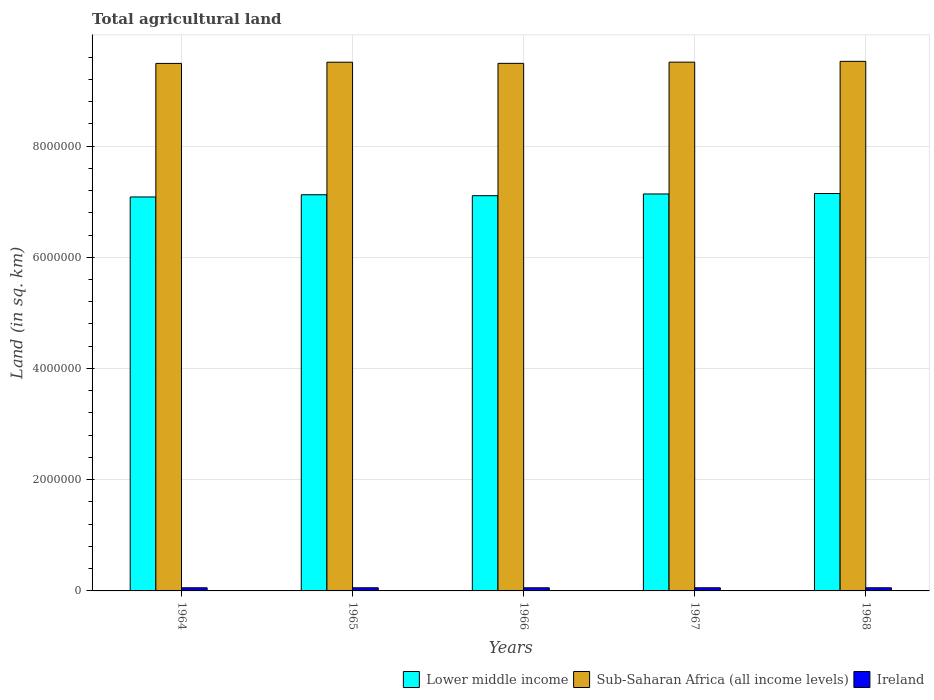What is the label of the 3rd group of bars from the left?
Offer a terse response. 1966. What is the total agricultural land in Lower middle income in 1967?
Ensure brevity in your answer.  7.14e+06. Across all years, what is the maximum total agricultural land in Ireland?
Keep it short and to the point. 5.67e+04. Across all years, what is the minimum total agricultural land in Ireland?
Make the answer very short. 5.64e+04. In which year was the total agricultural land in Lower middle income maximum?
Give a very brief answer. 1968. In which year was the total agricultural land in Sub-Saharan Africa (all income levels) minimum?
Make the answer very short. 1964. What is the total total agricultural land in Sub-Saharan Africa (all income levels) in the graph?
Your answer should be very brief. 4.75e+07. What is the difference between the total agricultural land in Lower middle income in 1965 and that in 1966?
Make the answer very short. 1.69e+04. What is the difference between the total agricultural land in Sub-Saharan Africa (all income levels) in 1968 and the total agricultural land in Ireland in 1964?
Provide a short and direct response. 9.47e+06. What is the average total agricultural land in Sub-Saharan Africa (all income levels) per year?
Provide a succinct answer. 9.50e+06. In the year 1964, what is the difference between the total agricultural land in Lower middle income and total agricultural land in Ireland?
Offer a very short reply. 7.03e+06. In how many years, is the total agricultural land in Lower middle income greater than 3200000 sq.km?
Make the answer very short. 5. What is the ratio of the total agricultural land in Sub-Saharan Africa (all income levels) in 1964 to that in 1968?
Keep it short and to the point. 1. Is the total agricultural land in Ireland in 1966 less than that in 1968?
Give a very brief answer. Yes. Is the difference between the total agricultural land in Lower middle income in 1967 and 1968 greater than the difference between the total agricultural land in Ireland in 1967 and 1968?
Provide a succinct answer. No. What is the difference between the highest and the second highest total agricultural land in Sub-Saharan Africa (all income levels)?
Your response must be concise. 1.42e+04. What is the difference between the highest and the lowest total agricultural land in Sub-Saharan Africa (all income levels)?
Ensure brevity in your answer.  3.70e+04. What does the 2nd bar from the left in 1966 represents?
Offer a terse response. Sub-Saharan Africa (all income levels). What does the 2nd bar from the right in 1967 represents?
Your response must be concise. Sub-Saharan Africa (all income levels). Is it the case that in every year, the sum of the total agricultural land in Lower middle income and total agricultural land in Sub-Saharan Africa (all income levels) is greater than the total agricultural land in Ireland?
Make the answer very short. Yes. Are all the bars in the graph horizontal?
Offer a very short reply. No. How many years are there in the graph?
Your answer should be compact. 5. What is the difference between two consecutive major ticks on the Y-axis?
Offer a terse response. 2.00e+06. Where does the legend appear in the graph?
Keep it short and to the point. Bottom right. How many legend labels are there?
Offer a terse response. 3. How are the legend labels stacked?
Your response must be concise. Horizontal. What is the title of the graph?
Your answer should be very brief. Total agricultural land. Does "Tunisia" appear as one of the legend labels in the graph?
Your answer should be compact. No. What is the label or title of the Y-axis?
Keep it short and to the point. Land (in sq. km). What is the Land (in sq. km) of Lower middle income in 1964?
Ensure brevity in your answer.  7.08e+06. What is the Land (in sq. km) in Sub-Saharan Africa (all income levels) in 1964?
Keep it short and to the point. 9.49e+06. What is the Land (in sq. km) in Ireland in 1964?
Your answer should be compact. 5.67e+04. What is the Land (in sq. km) of Lower middle income in 1965?
Make the answer very short. 7.12e+06. What is the Land (in sq. km) in Sub-Saharan Africa (all income levels) in 1965?
Your answer should be very brief. 9.51e+06. What is the Land (in sq. km) in Ireland in 1965?
Make the answer very short. 5.66e+04. What is the Land (in sq. km) in Lower middle income in 1966?
Offer a very short reply. 7.11e+06. What is the Land (in sq. km) in Sub-Saharan Africa (all income levels) in 1966?
Give a very brief answer. 9.49e+06. What is the Land (in sq. km) in Ireland in 1966?
Give a very brief answer. 5.64e+04. What is the Land (in sq. km) of Lower middle income in 1967?
Ensure brevity in your answer.  7.14e+06. What is the Land (in sq. km) of Sub-Saharan Africa (all income levels) in 1967?
Your response must be concise. 9.51e+06. What is the Land (in sq. km) in Ireland in 1967?
Ensure brevity in your answer.  5.65e+04. What is the Land (in sq. km) of Lower middle income in 1968?
Provide a short and direct response. 7.15e+06. What is the Land (in sq. km) of Sub-Saharan Africa (all income levels) in 1968?
Your answer should be compact. 9.52e+06. What is the Land (in sq. km) in Ireland in 1968?
Your answer should be very brief. 5.67e+04. Across all years, what is the maximum Land (in sq. km) of Lower middle income?
Ensure brevity in your answer.  7.15e+06. Across all years, what is the maximum Land (in sq. km) in Sub-Saharan Africa (all income levels)?
Provide a short and direct response. 9.52e+06. Across all years, what is the maximum Land (in sq. km) of Ireland?
Your response must be concise. 5.67e+04. Across all years, what is the minimum Land (in sq. km) of Lower middle income?
Make the answer very short. 7.08e+06. Across all years, what is the minimum Land (in sq. km) of Sub-Saharan Africa (all income levels)?
Ensure brevity in your answer.  9.49e+06. Across all years, what is the minimum Land (in sq. km) in Ireland?
Ensure brevity in your answer.  5.64e+04. What is the total Land (in sq. km) of Lower middle income in the graph?
Your answer should be compact. 3.56e+07. What is the total Land (in sq. km) of Sub-Saharan Africa (all income levels) in the graph?
Provide a succinct answer. 4.75e+07. What is the total Land (in sq. km) in Ireland in the graph?
Ensure brevity in your answer.  2.83e+05. What is the difference between the Land (in sq. km) of Lower middle income in 1964 and that in 1965?
Keep it short and to the point. -3.97e+04. What is the difference between the Land (in sq. km) of Sub-Saharan Africa (all income levels) in 1964 and that in 1965?
Keep it short and to the point. -2.16e+04. What is the difference between the Land (in sq. km) of Lower middle income in 1964 and that in 1966?
Your answer should be compact. -2.28e+04. What is the difference between the Land (in sq. km) in Sub-Saharan Africa (all income levels) in 1964 and that in 1966?
Make the answer very short. -1059.2. What is the difference between the Land (in sq. km) of Ireland in 1964 and that in 1966?
Ensure brevity in your answer.  310. What is the difference between the Land (in sq. km) in Lower middle income in 1964 and that in 1967?
Your answer should be very brief. -5.39e+04. What is the difference between the Land (in sq. km) of Sub-Saharan Africa (all income levels) in 1964 and that in 1967?
Keep it short and to the point. -2.28e+04. What is the difference between the Land (in sq. km) in Ireland in 1964 and that in 1967?
Provide a succinct answer. 120. What is the difference between the Land (in sq. km) of Lower middle income in 1964 and that in 1968?
Your response must be concise. -6.18e+04. What is the difference between the Land (in sq. km) of Sub-Saharan Africa (all income levels) in 1964 and that in 1968?
Your response must be concise. -3.70e+04. What is the difference between the Land (in sq. km) in Ireland in 1964 and that in 1968?
Offer a very short reply. -80. What is the difference between the Land (in sq. km) of Lower middle income in 1965 and that in 1966?
Make the answer very short. 1.69e+04. What is the difference between the Land (in sq. km) of Sub-Saharan Africa (all income levels) in 1965 and that in 1966?
Make the answer very short. 2.05e+04. What is the difference between the Land (in sq. km) of Ireland in 1965 and that in 1966?
Give a very brief answer. 270. What is the difference between the Land (in sq. km) of Lower middle income in 1965 and that in 1967?
Your answer should be compact. -1.42e+04. What is the difference between the Land (in sq. km) of Sub-Saharan Africa (all income levels) in 1965 and that in 1967?
Provide a succinct answer. -1287.4. What is the difference between the Land (in sq. km) of Ireland in 1965 and that in 1967?
Give a very brief answer. 80. What is the difference between the Land (in sq. km) in Lower middle income in 1965 and that in 1968?
Provide a succinct answer. -2.21e+04. What is the difference between the Land (in sq. km) of Sub-Saharan Africa (all income levels) in 1965 and that in 1968?
Provide a succinct answer. -1.55e+04. What is the difference between the Land (in sq. km) of Ireland in 1965 and that in 1968?
Offer a very short reply. -120. What is the difference between the Land (in sq. km) in Lower middle income in 1966 and that in 1967?
Your response must be concise. -3.10e+04. What is the difference between the Land (in sq. km) of Sub-Saharan Africa (all income levels) in 1966 and that in 1967?
Keep it short and to the point. -2.18e+04. What is the difference between the Land (in sq. km) in Ireland in 1966 and that in 1967?
Your response must be concise. -190. What is the difference between the Land (in sq. km) of Lower middle income in 1966 and that in 1968?
Provide a succinct answer. -3.90e+04. What is the difference between the Land (in sq. km) of Sub-Saharan Africa (all income levels) in 1966 and that in 1968?
Your answer should be compact. -3.60e+04. What is the difference between the Land (in sq. km) in Ireland in 1966 and that in 1968?
Ensure brevity in your answer.  -390. What is the difference between the Land (in sq. km) in Lower middle income in 1967 and that in 1968?
Provide a succinct answer. -7960.8. What is the difference between the Land (in sq. km) in Sub-Saharan Africa (all income levels) in 1967 and that in 1968?
Your answer should be very brief. -1.42e+04. What is the difference between the Land (in sq. km) in Ireland in 1967 and that in 1968?
Give a very brief answer. -200. What is the difference between the Land (in sq. km) of Lower middle income in 1964 and the Land (in sq. km) of Sub-Saharan Africa (all income levels) in 1965?
Give a very brief answer. -2.42e+06. What is the difference between the Land (in sq. km) in Lower middle income in 1964 and the Land (in sq. km) in Ireland in 1965?
Give a very brief answer. 7.03e+06. What is the difference between the Land (in sq. km) of Sub-Saharan Africa (all income levels) in 1964 and the Land (in sq. km) of Ireland in 1965?
Keep it short and to the point. 9.43e+06. What is the difference between the Land (in sq. km) in Lower middle income in 1964 and the Land (in sq. km) in Sub-Saharan Africa (all income levels) in 1966?
Offer a terse response. -2.40e+06. What is the difference between the Land (in sq. km) in Lower middle income in 1964 and the Land (in sq. km) in Ireland in 1966?
Your answer should be very brief. 7.03e+06. What is the difference between the Land (in sq. km) of Sub-Saharan Africa (all income levels) in 1964 and the Land (in sq. km) of Ireland in 1966?
Offer a very short reply. 9.43e+06. What is the difference between the Land (in sq. km) of Lower middle income in 1964 and the Land (in sq. km) of Sub-Saharan Africa (all income levels) in 1967?
Give a very brief answer. -2.42e+06. What is the difference between the Land (in sq. km) in Lower middle income in 1964 and the Land (in sq. km) in Ireland in 1967?
Your response must be concise. 7.03e+06. What is the difference between the Land (in sq. km) of Sub-Saharan Africa (all income levels) in 1964 and the Land (in sq. km) of Ireland in 1967?
Your answer should be compact. 9.43e+06. What is the difference between the Land (in sq. km) of Lower middle income in 1964 and the Land (in sq. km) of Sub-Saharan Africa (all income levels) in 1968?
Keep it short and to the point. -2.44e+06. What is the difference between the Land (in sq. km) of Lower middle income in 1964 and the Land (in sq. km) of Ireland in 1968?
Your response must be concise. 7.03e+06. What is the difference between the Land (in sq. km) of Sub-Saharan Africa (all income levels) in 1964 and the Land (in sq. km) of Ireland in 1968?
Keep it short and to the point. 9.43e+06. What is the difference between the Land (in sq. km) of Lower middle income in 1965 and the Land (in sq. km) of Sub-Saharan Africa (all income levels) in 1966?
Give a very brief answer. -2.36e+06. What is the difference between the Land (in sq. km) of Lower middle income in 1965 and the Land (in sq. km) of Ireland in 1966?
Make the answer very short. 7.07e+06. What is the difference between the Land (in sq. km) in Sub-Saharan Africa (all income levels) in 1965 and the Land (in sq. km) in Ireland in 1966?
Keep it short and to the point. 9.45e+06. What is the difference between the Land (in sq. km) in Lower middle income in 1965 and the Land (in sq. km) in Sub-Saharan Africa (all income levels) in 1967?
Your answer should be compact. -2.38e+06. What is the difference between the Land (in sq. km) of Lower middle income in 1965 and the Land (in sq. km) of Ireland in 1967?
Offer a very short reply. 7.07e+06. What is the difference between the Land (in sq. km) of Sub-Saharan Africa (all income levels) in 1965 and the Land (in sq. km) of Ireland in 1967?
Offer a terse response. 9.45e+06. What is the difference between the Land (in sq. km) of Lower middle income in 1965 and the Land (in sq. km) of Sub-Saharan Africa (all income levels) in 1968?
Your response must be concise. -2.40e+06. What is the difference between the Land (in sq. km) of Lower middle income in 1965 and the Land (in sq. km) of Ireland in 1968?
Ensure brevity in your answer.  7.07e+06. What is the difference between the Land (in sq. km) of Sub-Saharan Africa (all income levels) in 1965 and the Land (in sq. km) of Ireland in 1968?
Offer a terse response. 9.45e+06. What is the difference between the Land (in sq. km) of Lower middle income in 1966 and the Land (in sq. km) of Sub-Saharan Africa (all income levels) in 1967?
Keep it short and to the point. -2.40e+06. What is the difference between the Land (in sq. km) of Lower middle income in 1966 and the Land (in sq. km) of Ireland in 1967?
Keep it short and to the point. 7.05e+06. What is the difference between the Land (in sq. km) of Sub-Saharan Africa (all income levels) in 1966 and the Land (in sq. km) of Ireland in 1967?
Your answer should be compact. 9.43e+06. What is the difference between the Land (in sq. km) of Lower middle income in 1966 and the Land (in sq. km) of Sub-Saharan Africa (all income levels) in 1968?
Keep it short and to the point. -2.42e+06. What is the difference between the Land (in sq. km) in Lower middle income in 1966 and the Land (in sq. km) in Ireland in 1968?
Offer a terse response. 7.05e+06. What is the difference between the Land (in sq. km) of Sub-Saharan Africa (all income levels) in 1966 and the Land (in sq. km) of Ireland in 1968?
Keep it short and to the point. 9.43e+06. What is the difference between the Land (in sq. km) in Lower middle income in 1967 and the Land (in sq. km) in Sub-Saharan Africa (all income levels) in 1968?
Your answer should be very brief. -2.38e+06. What is the difference between the Land (in sq. km) of Lower middle income in 1967 and the Land (in sq. km) of Ireland in 1968?
Provide a short and direct response. 7.08e+06. What is the difference between the Land (in sq. km) in Sub-Saharan Africa (all income levels) in 1967 and the Land (in sq. km) in Ireland in 1968?
Offer a terse response. 9.45e+06. What is the average Land (in sq. km) of Lower middle income per year?
Make the answer very short. 7.12e+06. What is the average Land (in sq. km) in Sub-Saharan Africa (all income levels) per year?
Ensure brevity in your answer.  9.50e+06. What is the average Land (in sq. km) of Ireland per year?
Provide a short and direct response. 5.66e+04. In the year 1964, what is the difference between the Land (in sq. km) of Lower middle income and Land (in sq. km) of Sub-Saharan Africa (all income levels)?
Provide a short and direct response. -2.40e+06. In the year 1964, what is the difference between the Land (in sq. km) in Lower middle income and Land (in sq. km) in Ireland?
Give a very brief answer. 7.03e+06. In the year 1964, what is the difference between the Land (in sq. km) in Sub-Saharan Africa (all income levels) and Land (in sq. km) in Ireland?
Make the answer very short. 9.43e+06. In the year 1965, what is the difference between the Land (in sq. km) of Lower middle income and Land (in sq. km) of Sub-Saharan Africa (all income levels)?
Your answer should be very brief. -2.38e+06. In the year 1965, what is the difference between the Land (in sq. km) of Lower middle income and Land (in sq. km) of Ireland?
Your answer should be compact. 7.07e+06. In the year 1965, what is the difference between the Land (in sq. km) of Sub-Saharan Africa (all income levels) and Land (in sq. km) of Ireland?
Offer a very short reply. 9.45e+06. In the year 1966, what is the difference between the Land (in sq. km) of Lower middle income and Land (in sq. km) of Sub-Saharan Africa (all income levels)?
Keep it short and to the point. -2.38e+06. In the year 1966, what is the difference between the Land (in sq. km) of Lower middle income and Land (in sq. km) of Ireland?
Provide a succinct answer. 7.05e+06. In the year 1966, what is the difference between the Land (in sq. km) of Sub-Saharan Africa (all income levels) and Land (in sq. km) of Ireland?
Ensure brevity in your answer.  9.43e+06. In the year 1967, what is the difference between the Land (in sq. km) of Lower middle income and Land (in sq. km) of Sub-Saharan Africa (all income levels)?
Offer a very short reply. -2.37e+06. In the year 1967, what is the difference between the Land (in sq. km) of Lower middle income and Land (in sq. km) of Ireland?
Your answer should be very brief. 7.08e+06. In the year 1967, what is the difference between the Land (in sq. km) in Sub-Saharan Africa (all income levels) and Land (in sq. km) in Ireland?
Make the answer very short. 9.45e+06. In the year 1968, what is the difference between the Land (in sq. km) in Lower middle income and Land (in sq. km) in Sub-Saharan Africa (all income levels)?
Offer a very short reply. -2.38e+06. In the year 1968, what is the difference between the Land (in sq. km) in Lower middle income and Land (in sq. km) in Ireland?
Offer a very short reply. 7.09e+06. In the year 1968, what is the difference between the Land (in sq. km) of Sub-Saharan Africa (all income levels) and Land (in sq. km) of Ireland?
Make the answer very short. 9.47e+06. What is the ratio of the Land (in sq. km) of Lower middle income in 1964 to that in 1965?
Offer a terse response. 0.99. What is the ratio of the Land (in sq. km) in Sub-Saharan Africa (all income levels) in 1964 to that in 1965?
Ensure brevity in your answer.  1. What is the ratio of the Land (in sq. km) of Ireland in 1964 to that in 1965?
Give a very brief answer. 1. What is the ratio of the Land (in sq. km) of Lower middle income in 1964 to that in 1966?
Your answer should be compact. 1. What is the ratio of the Land (in sq. km) in Sub-Saharan Africa (all income levels) in 1964 to that in 1966?
Your response must be concise. 1. What is the ratio of the Land (in sq. km) of Lower middle income in 1964 to that in 1967?
Keep it short and to the point. 0.99. What is the ratio of the Land (in sq. km) in Sub-Saharan Africa (all income levels) in 1964 to that in 1967?
Provide a short and direct response. 1. What is the ratio of the Land (in sq. km) of Ireland in 1964 to that in 1967?
Make the answer very short. 1. What is the ratio of the Land (in sq. km) of Ireland in 1964 to that in 1968?
Offer a very short reply. 1. What is the ratio of the Land (in sq. km) in Lower middle income in 1965 to that in 1966?
Offer a very short reply. 1. What is the ratio of the Land (in sq. km) in Sub-Saharan Africa (all income levels) in 1965 to that in 1966?
Your answer should be very brief. 1. What is the ratio of the Land (in sq. km) in Ireland in 1965 to that in 1966?
Ensure brevity in your answer.  1. What is the ratio of the Land (in sq. km) of Lower middle income in 1965 to that in 1967?
Give a very brief answer. 1. What is the ratio of the Land (in sq. km) of Ireland in 1965 to that in 1967?
Ensure brevity in your answer.  1. What is the ratio of the Land (in sq. km) of Lower middle income in 1965 to that in 1968?
Offer a terse response. 1. What is the ratio of the Land (in sq. km) in Sub-Saharan Africa (all income levels) in 1965 to that in 1968?
Your answer should be compact. 1. What is the ratio of the Land (in sq. km) of Ireland in 1965 to that in 1968?
Provide a succinct answer. 1. What is the ratio of the Land (in sq. km) of Lower middle income in 1966 to that in 1967?
Ensure brevity in your answer.  1. What is the ratio of the Land (in sq. km) of Sub-Saharan Africa (all income levels) in 1966 to that in 1967?
Offer a very short reply. 1. What is the ratio of the Land (in sq. km) of Ireland in 1966 to that in 1968?
Your answer should be very brief. 0.99. What is the ratio of the Land (in sq. km) of Sub-Saharan Africa (all income levels) in 1967 to that in 1968?
Provide a succinct answer. 1. What is the difference between the highest and the second highest Land (in sq. km) in Lower middle income?
Keep it short and to the point. 7960.8. What is the difference between the highest and the second highest Land (in sq. km) in Sub-Saharan Africa (all income levels)?
Your answer should be very brief. 1.42e+04. What is the difference between the highest and the second highest Land (in sq. km) of Ireland?
Provide a succinct answer. 80. What is the difference between the highest and the lowest Land (in sq. km) in Lower middle income?
Offer a terse response. 6.18e+04. What is the difference between the highest and the lowest Land (in sq. km) of Sub-Saharan Africa (all income levels)?
Your response must be concise. 3.70e+04. What is the difference between the highest and the lowest Land (in sq. km) of Ireland?
Ensure brevity in your answer.  390. 